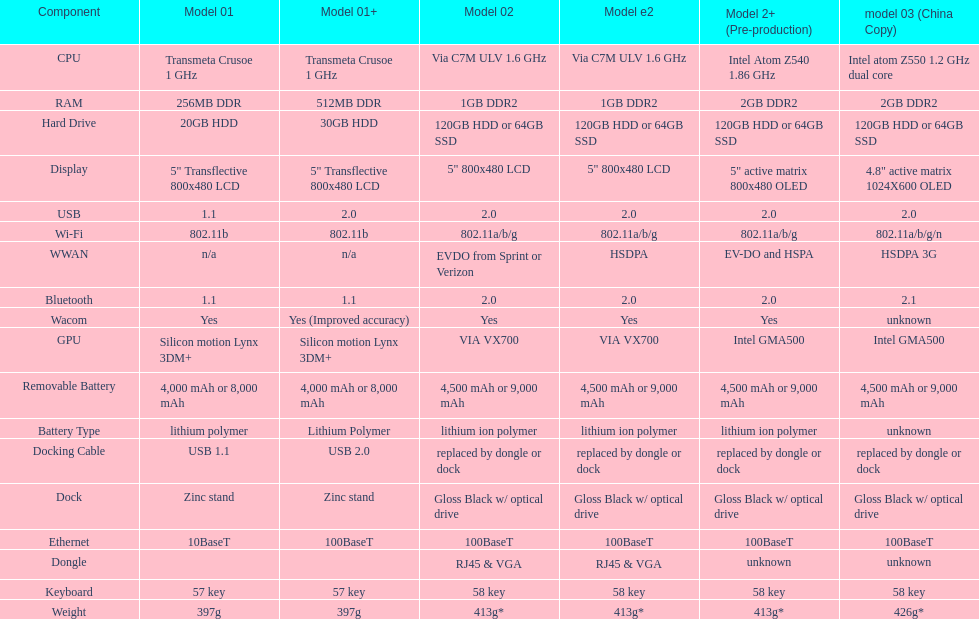How much heavier is the model 3 than the model 1? 29g. 